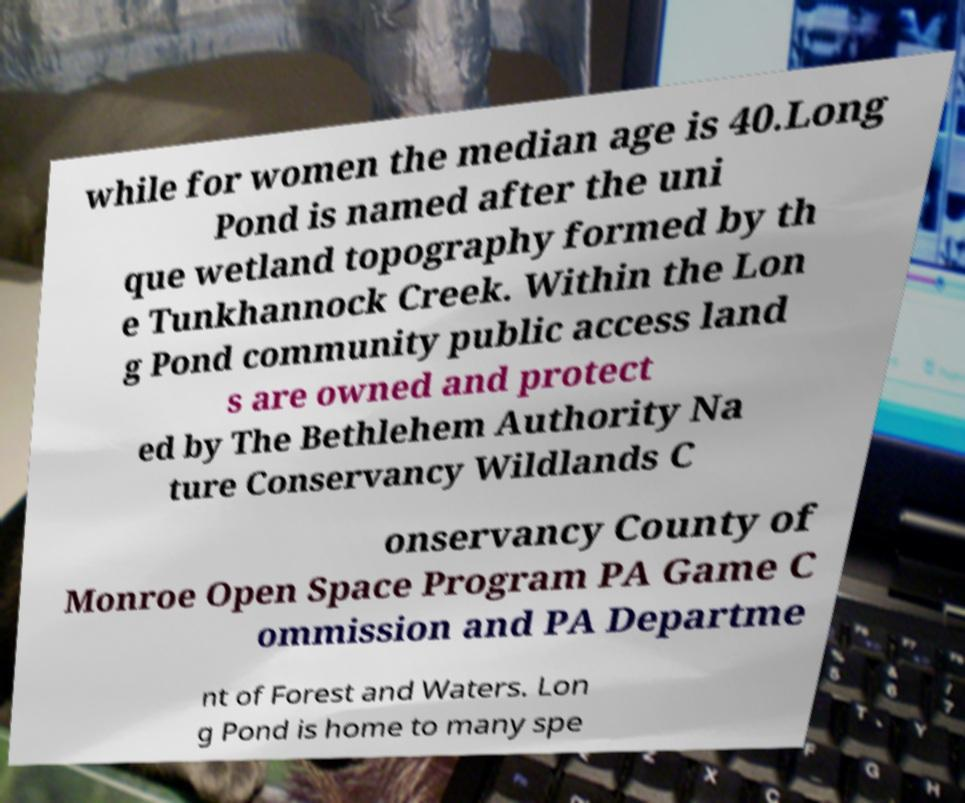Can you read and provide the text displayed in the image?This photo seems to have some interesting text. Can you extract and type it out for me? while for women the median age is 40.Long Pond is named after the uni que wetland topography formed by th e Tunkhannock Creek. Within the Lon g Pond community public access land s are owned and protect ed by The Bethlehem Authority Na ture Conservancy Wildlands C onservancy County of Monroe Open Space Program PA Game C ommission and PA Departme nt of Forest and Waters. Lon g Pond is home to many spe 